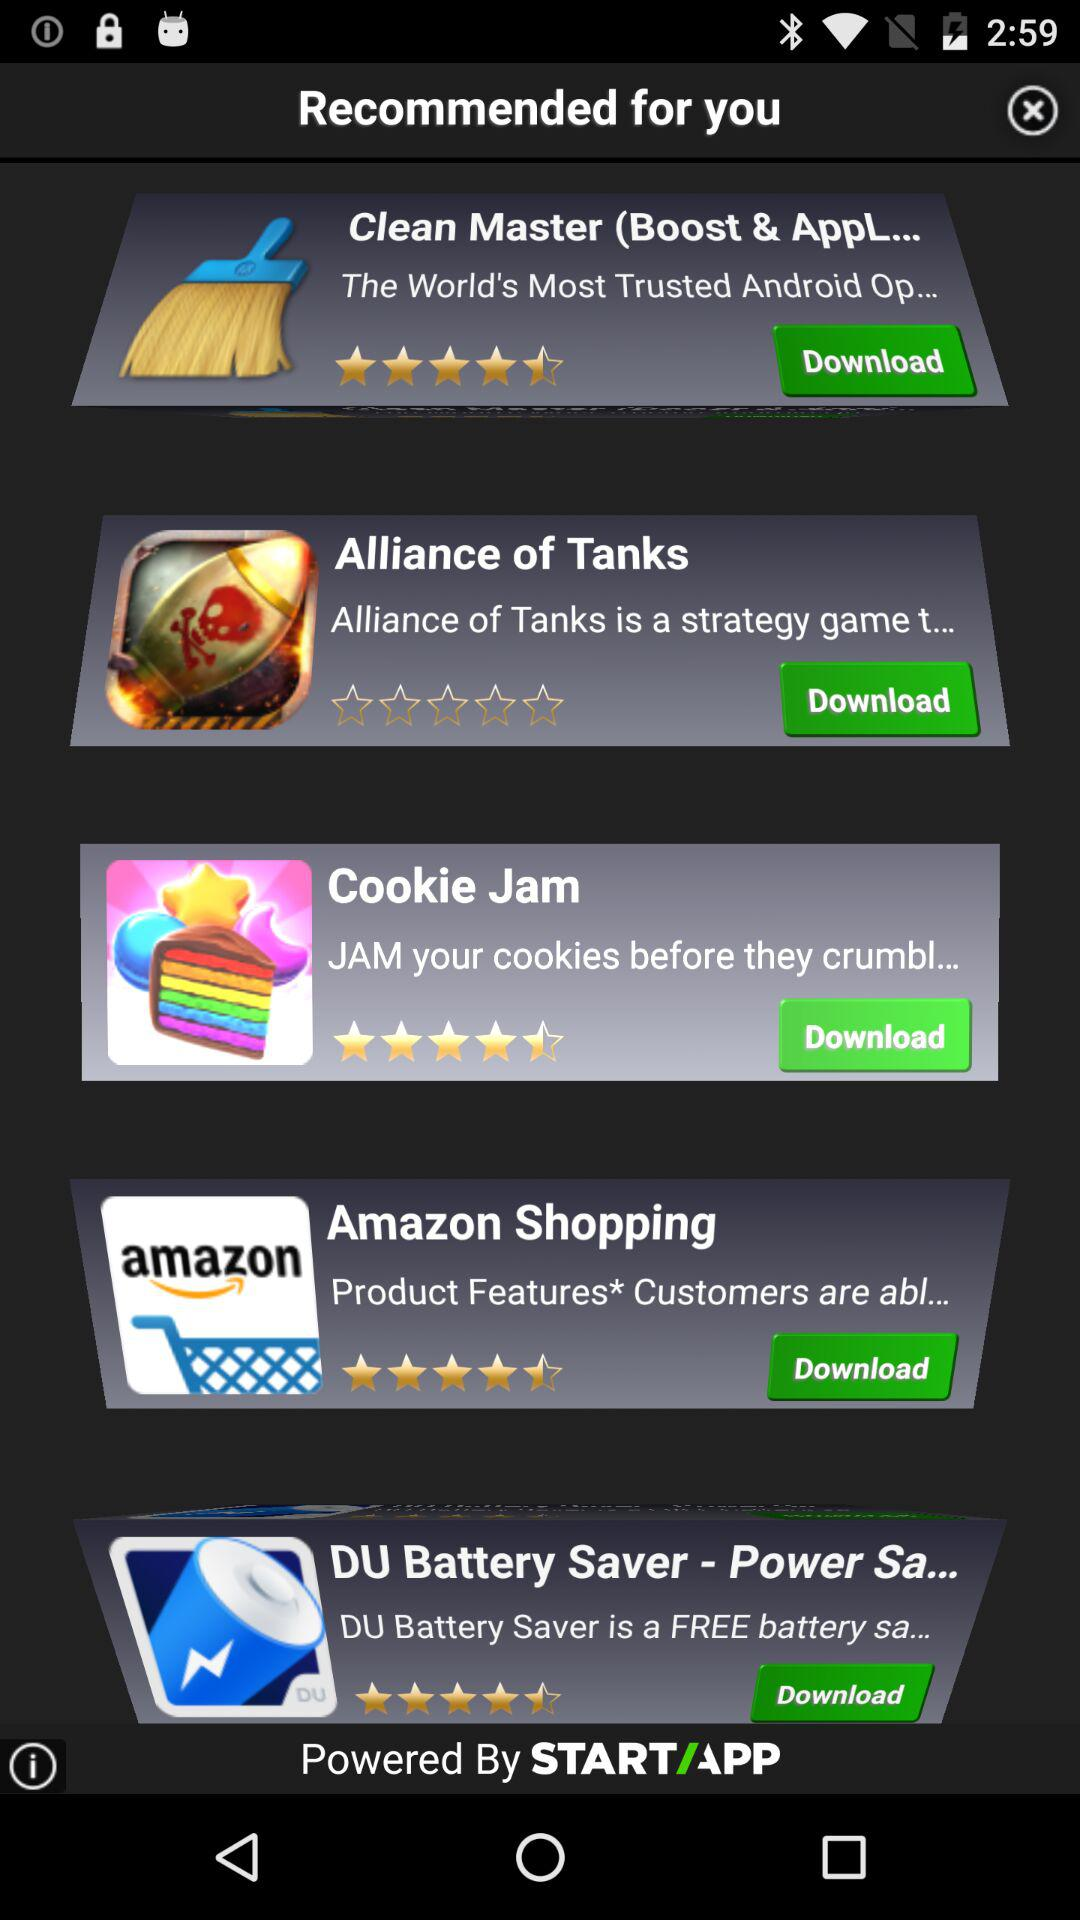What is the rating for "Cookie Jam"? The rating is 4.5 stars. 